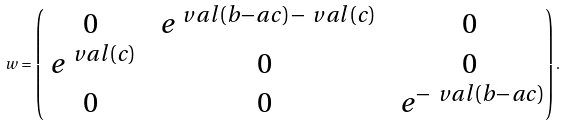<formula> <loc_0><loc_0><loc_500><loc_500>\ w = \begin{pmatrix} 0 & \ e ^ { \ v a l ( b - a c ) - \ v a l ( c ) } & 0 \\ \ e ^ { \ v a l ( c ) } & 0 & 0 \\ 0 & 0 & \ e ^ { - \ v a l ( b - a c ) } \end{pmatrix} .</formula> 